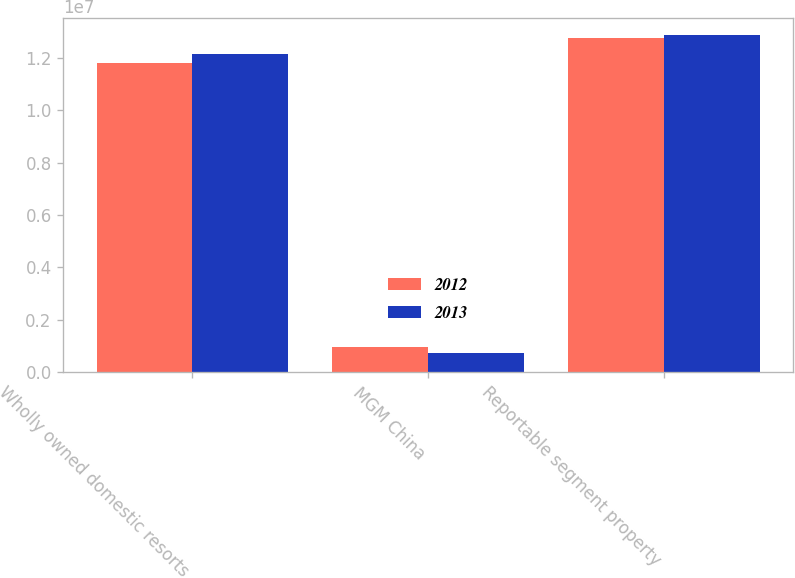<chart> <loc_0><loc_0><loc_500><loc_500><stacked_bar_chart><ecel><fcel>Wholly owned domestic resorts<fcel>MGM China<fcel>Reportable segment property<nl><fcel>2012<fcel>1.17879e+07<fcel>957769<fcel>1.27456e+07<nl><fcel>2013<fcel>1.21457e+07<fcel>737920<fcel>1.28836e+07<nl></chart> 